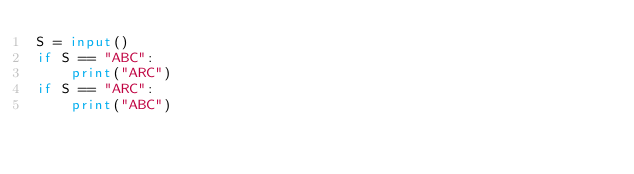<code> <loc_0><loc_0><loc_500><loc_500><_Python_>S = input()
if S == "ABC":
    print("ARC")
if S == "ARC":
    print("ABC")</code> 